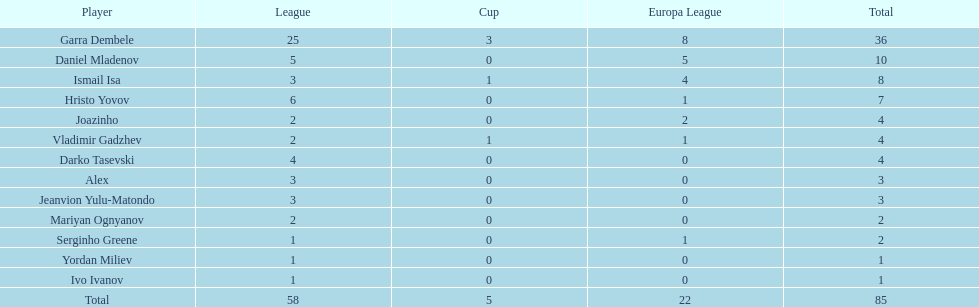Would you be able to parse every entry in this table? {'header': ['Player', 'League', 'Cup', 'Europa League', 'Total'], 'rows': [['Garra Dembele', '25', '3', '8', '36'], ['Daniel Mladenov', '5', '0', '5', '10'], ['Ismail Isa', '3', '1', '4', '8'], ['Hristo Yovov', '6', '0', '1', '7'], ['Joazinho', '2', '0', '2', '4'], ['Vladimir Gadzhev', '2', '1', '1', '4'], ['Darko Tasevski', '4', '0', '0', '4'], ['Alex', '3', '0', '0', '3'], ['Jeanvion Yulu-Matondo', '3', '0', '0', '3'], ['Mariyan Ognyanov', '2', '0', '0', '2'], ['Serginho Greene', '1', '0', '1', '2'], ['Yordan Miliev', '1', '0', '0', '1'], ['Ivo Ivanov', '1', '0', '0', '1'], ['Total', '58', '5', '22', '85']]} Who is a player in the same league as both joazinho and vladimir gadzhev? Mariyan Ognyanov. 